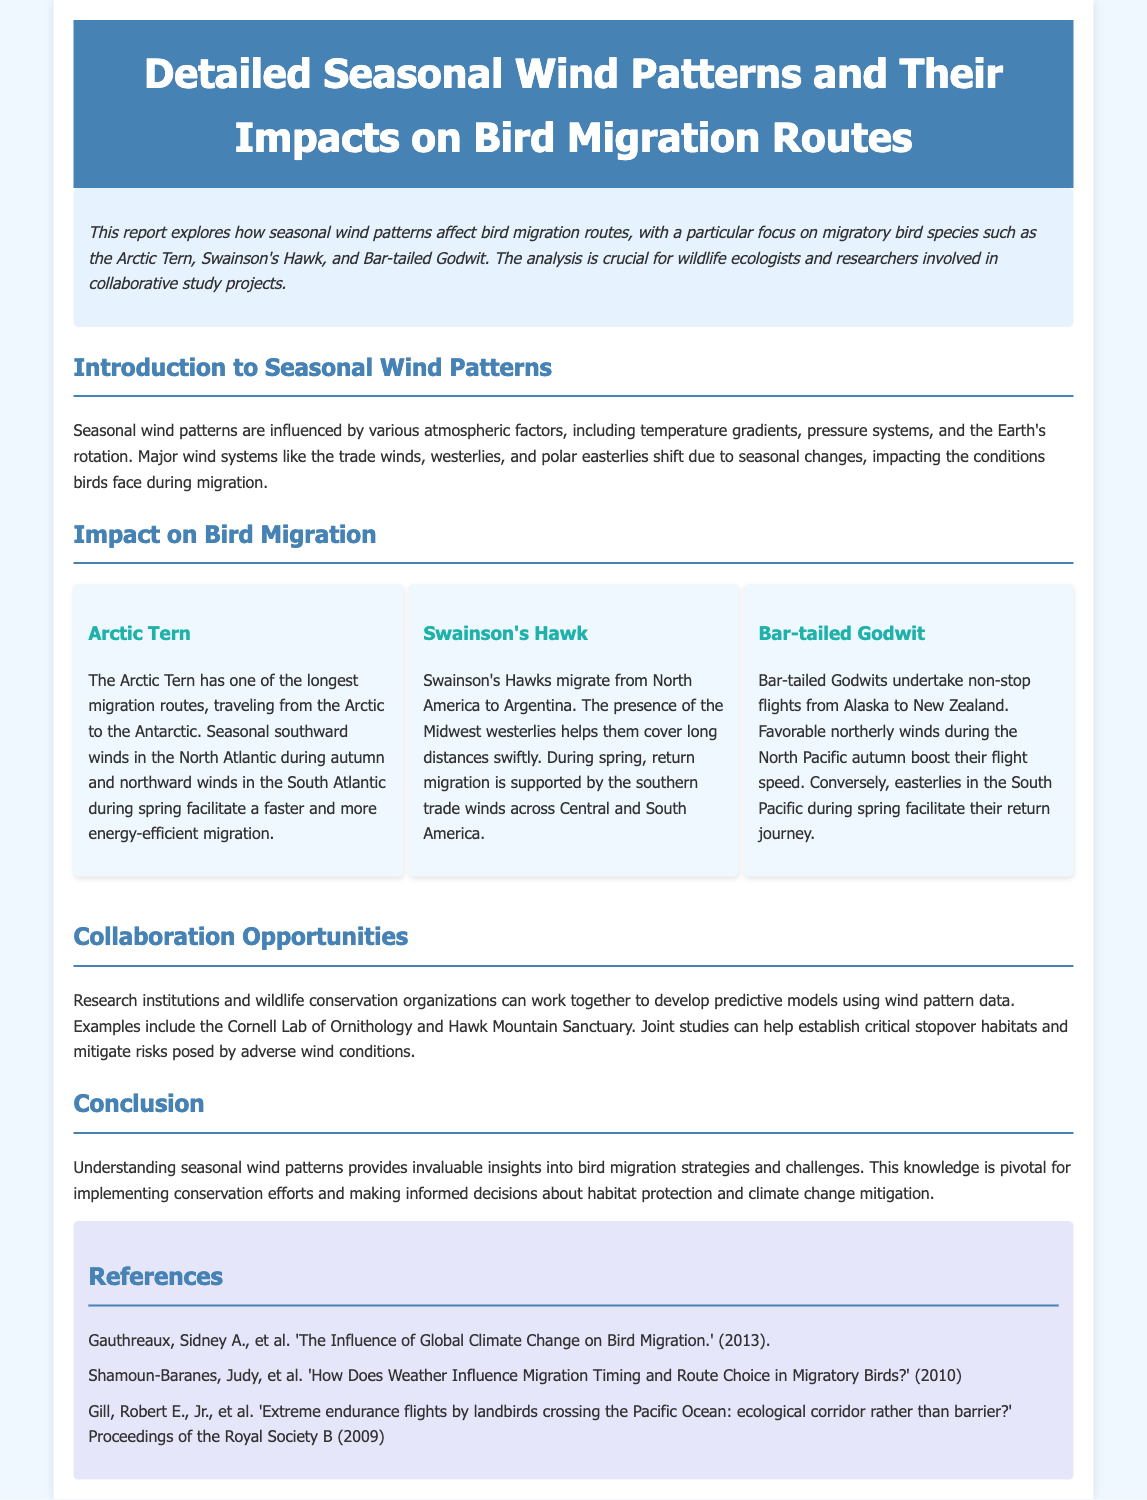What is the title of the report? The title of the report is stated at the top of the document.
Answer: Detailed Seasonal Wind Patterns and Their Impacts on Bird Migration Routes What species is mentioned as having one of the longest migration routes? The document specifically highlights a bird species known for its extensive migration journey.
Answer: Arctic Tern Which wind patterns assist the Swainson's Hawk during its return migration? The report details the wind patterns that facilitate migration for specific bird species.
Answer: southern trade winds What is a suggested collaboration opportunity mentioned in the report? The document discusses potential partnerships for research based on its content.
Answer: predictive models using wind pattern data How many bird species are analyzed in the document? The document provides information about specific bird species, focusing on three.
Answer: three What type of winds boost the flight speed of the Bar-tailed Godwit? The report describes the wind patterns beneficial for bird migration, including one for this species.
Answer: favorable northerly winds In which seasons do the Arctic Tern migrate? The report mentions migration patterns linked to seasonal changes for specific birds.
Answer: autumn and spring Who conducted research on the influence of global climate change on bird migration? The references section includes a citation relevant to climate change's effect on migration.
Answer: Gauthreaux, Sidney A 